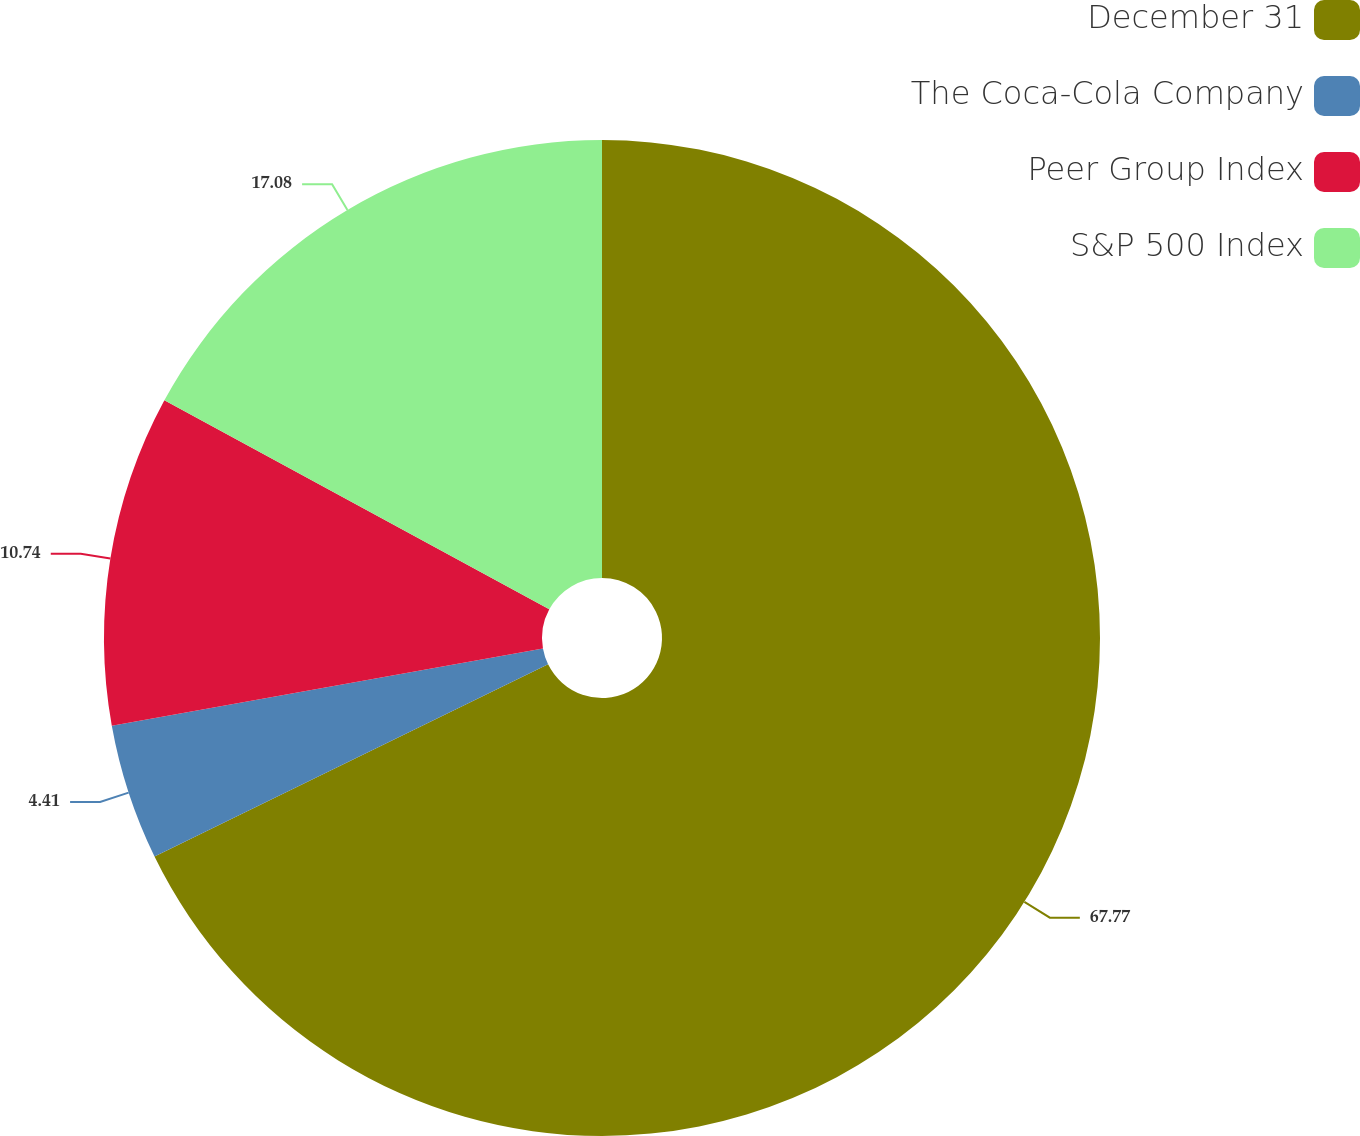<chart> <loc_0><loc_0><loc_500><loc_500><pie_chart><fcel>December 31<fcel>The Coca-Cola Company<fcel>Peer Group Index<fcel>S&P 500 Index<nl><fcel>67.77%<fcel>4.41%<fcel>10.74%<fcel>17.08%<nl></chart> 